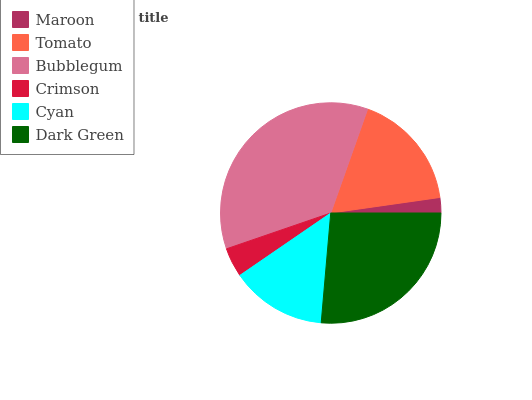Is Maroon the minimum?
Answer yes or no. Yes. Is Bubblegum the maximum?
Answer yes or no. Yes. Is Tomato the minimum?
Answer yes or no. No. Is Tomato the maximum?
Answer yes or no. No. Is Tomato greater than Maroon?
Answer yes or no. Yes. Is Maroon less than Tomato?
Answer yes or no. Yes. Is Maroon greater than Tomato?
Answer yes or no. No. Is Tomato less than Maroon?
Answer yes or no. No. Is Tomato the high median?
Answer yes or no. Yes. Is Cyan the low median?
Answer yes or no. Yes. Is Maroon the high median?
Answer yes or no. No. Is Dark Green the low median?
Answer yes or no. No. 